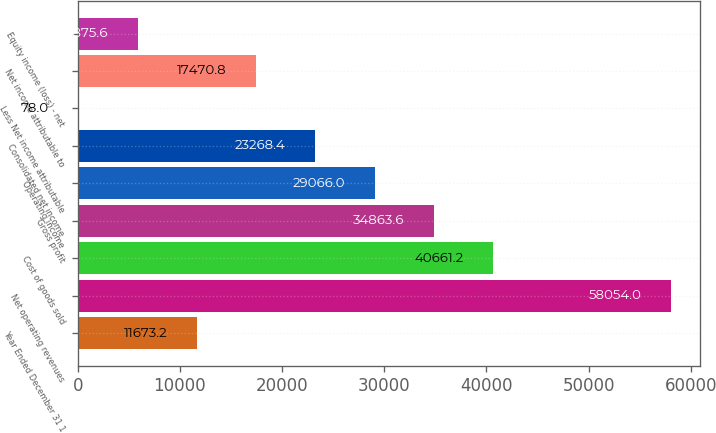<chart> <loc_0><loc_0><loc_500><loc_500><bar_chart><fcel>Year Ended December 31 1<fcel>Net operating revenues<fcel>Cost of goods sold<fcel>Gross profit<fcel>Operating income<fcel>Consolidated net income<fcel>Less Net income attributable<fcel>Net income attributable to<fcel>Equity income (loss) - net<nl><fcel>11673.2<fcel>58054<fcel>40661.2<fcel>34863.6<fcel>29066<fcel>23268.4<fcel>78<fcel>17470.8<fcel>5875.6<nl></chart> 